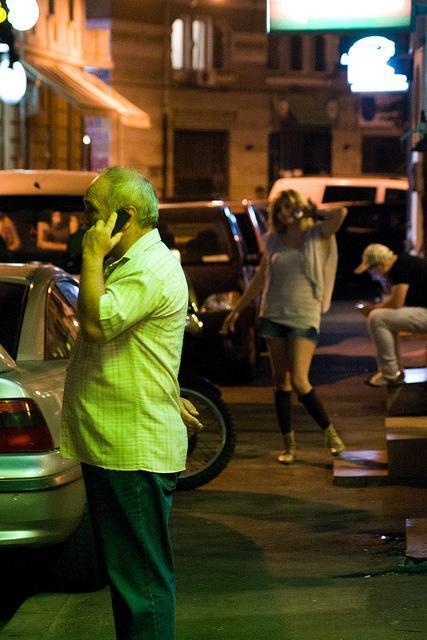How many cars are there?
Give a very brief answer. 5. How many people can be seen?
Give a very brief answer. 3. 